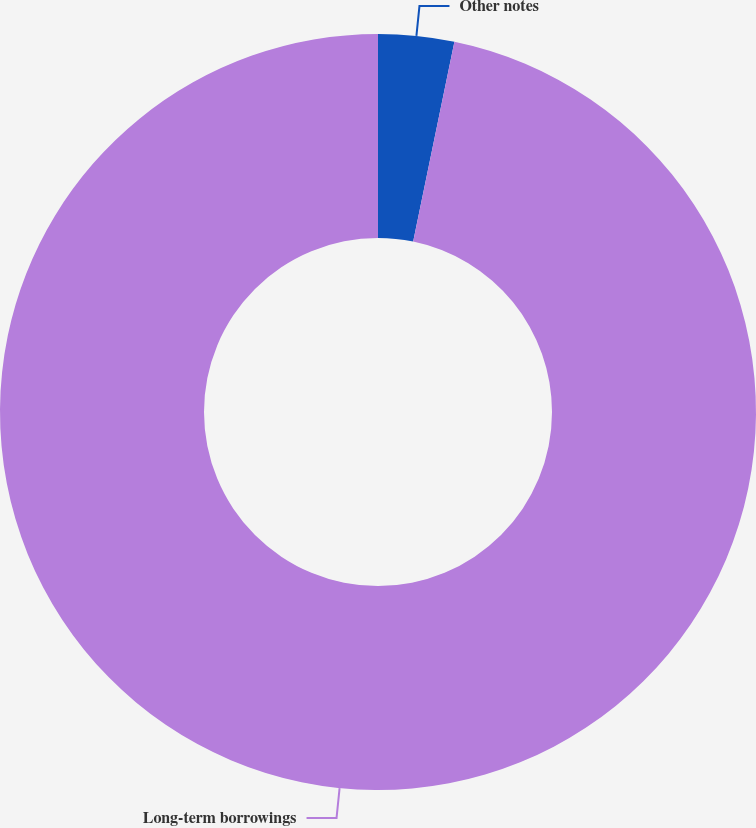<chart> <loc_0><loc_0><loc_500><loc_500><pie_chart><fcel>Other notes<fcel>Long-term borrowings<nl><fcel>3.24%<fcel>96.76%<nl></chart> 